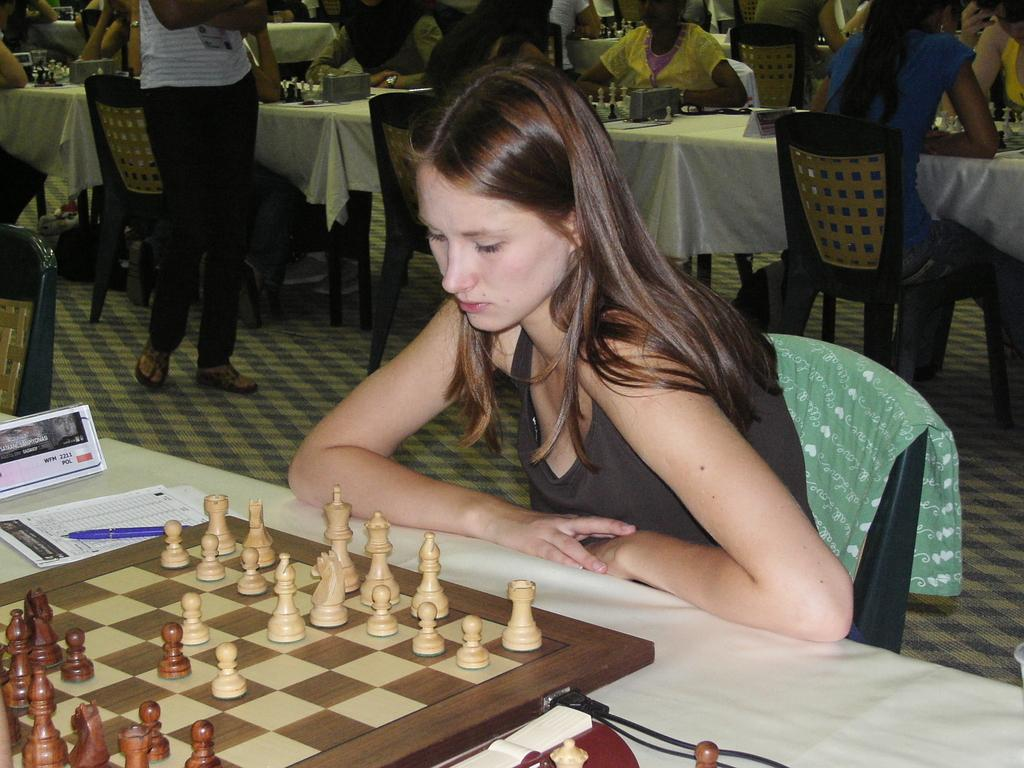What are the people in the image doing? The people in the image are sitting on chairs. What objects are present in the image that are typically used for eating or working? There are tables in the image. What can be seen on one of the tables? There is a poster, paper, and a pen on one of the tables. What type of game is set up on one of the tables? There is a chess board on one of the tables. What type of surprise can be seen on the chess board in the image? There is no surprise visible on the chess board in the image; it is a standard chess setup. 